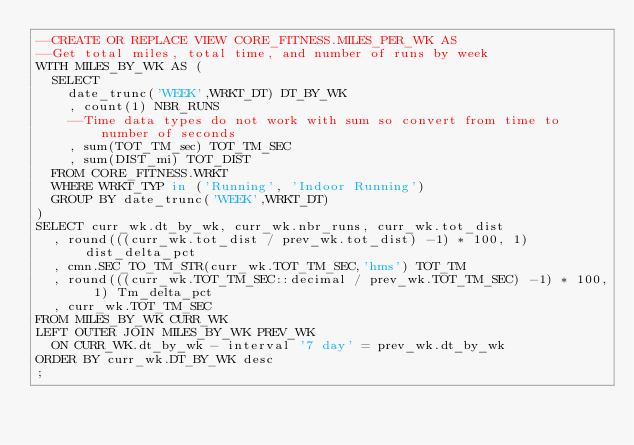Convert code to text. <code><loc_0><loc_0><loc_500><loc_500><_SQL_>--CREATE OR REPLACE VIEW CORE_FITNESS.MILES_PER_WK AS
--Get total miles, total time, and number of runs by week
WITH MILES_BY_WK AS (
  SELECT
    date_trunc('WEEK',WRKT_DT) DT_BY_WK
    , count(1) NBR_RUNS
    --Time data types do not work with sum so convert from time to number of seconds
    , sum(TOT_TM_sec) TOT_TM_SEC
    , sum(DIST_mi) TOT_DIST
  FROM CORE_FITNESS.WRKT
  WHERE WRKT_TYP in ('Running', 'Indoor Running')
  GROUP BY date_trunc('WEEK',WRKT_DT)
)
SELECT curr_wk.dt_by_wk, curr_wk.nbr_runs, curr_wk.tot_dist
  , round(((curr_wk.tot_dist / prev_wk.tot_dist) -1) * 100, 1) dist_delta_pct
  , cmn.SEC_TO_TM_STR(curr_wk.TOT_TM_SEC,'hms') TOT_TM
  , round(((curr_wk.TOT_TM_SEC::decimal / prev_wk.TOT_TM_SEC) -1) * 100, 1) Tm_delta_pct
  , curr_wk.TOT_TM_SEC
FROM MILES_BY_WK CURR_WK
LEFT OUTER JOIN MILES_BY_WK PREV_WK
  ON CURR_WK.dt_by_wk - interval '7 day' = prev_wk.dt_by_wk
ORDER BY curr_wk.DT_BY_WK desc
;
</code> 